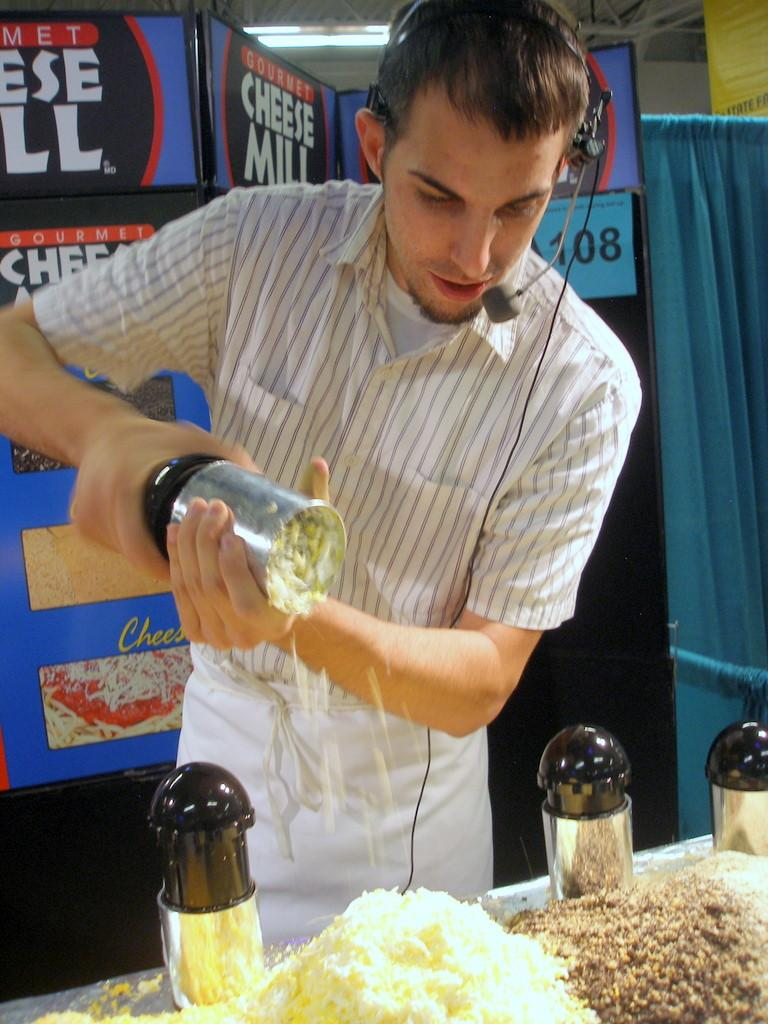<image>
Present a compact description of the photo's key features. A man doing a demonstration of a product called a Cheese Mill. 